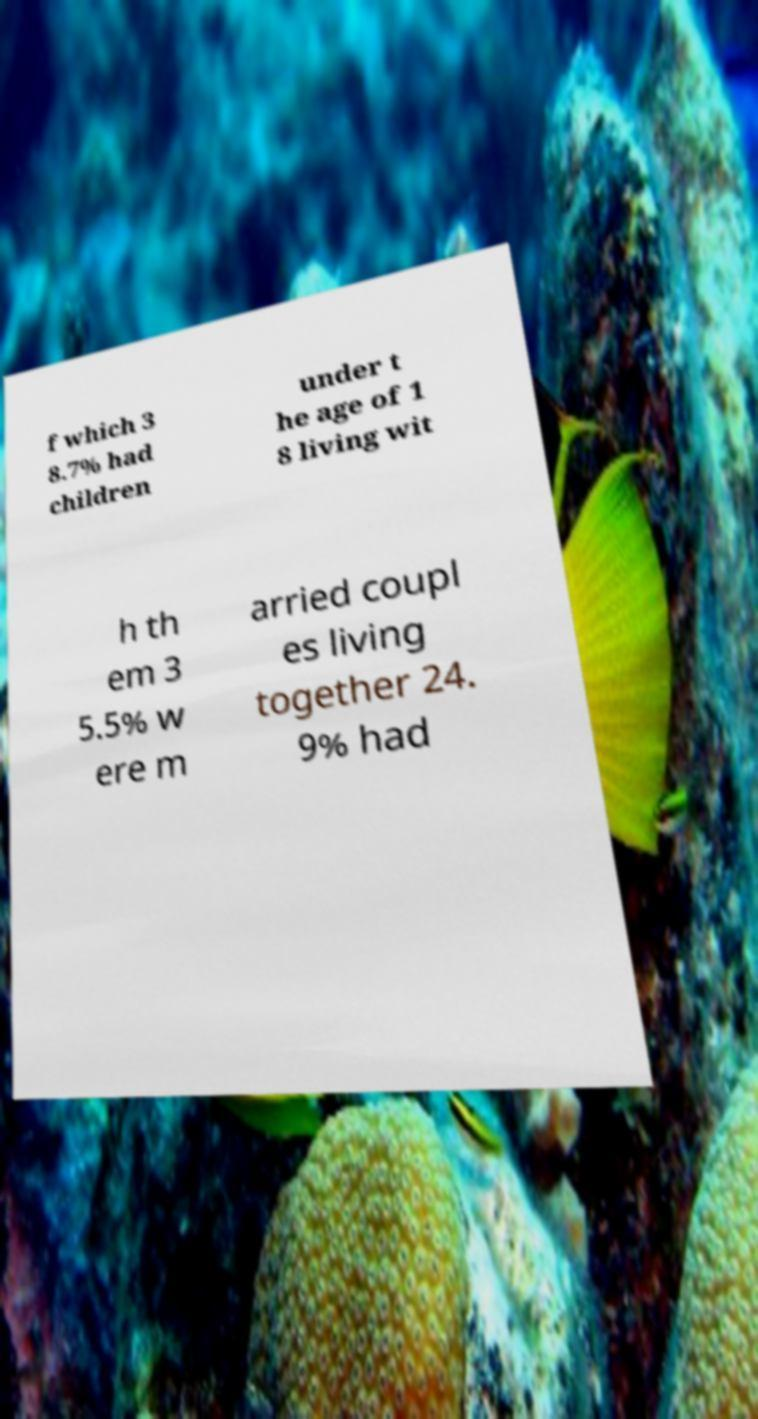What messages or text are displayed in this image? I need them in a readable, typed format. f which 3 8.7% had children under t he age of 1 8 living wit h th em 3 5.5% w ere m arried coupl es living together 24. 9% had 